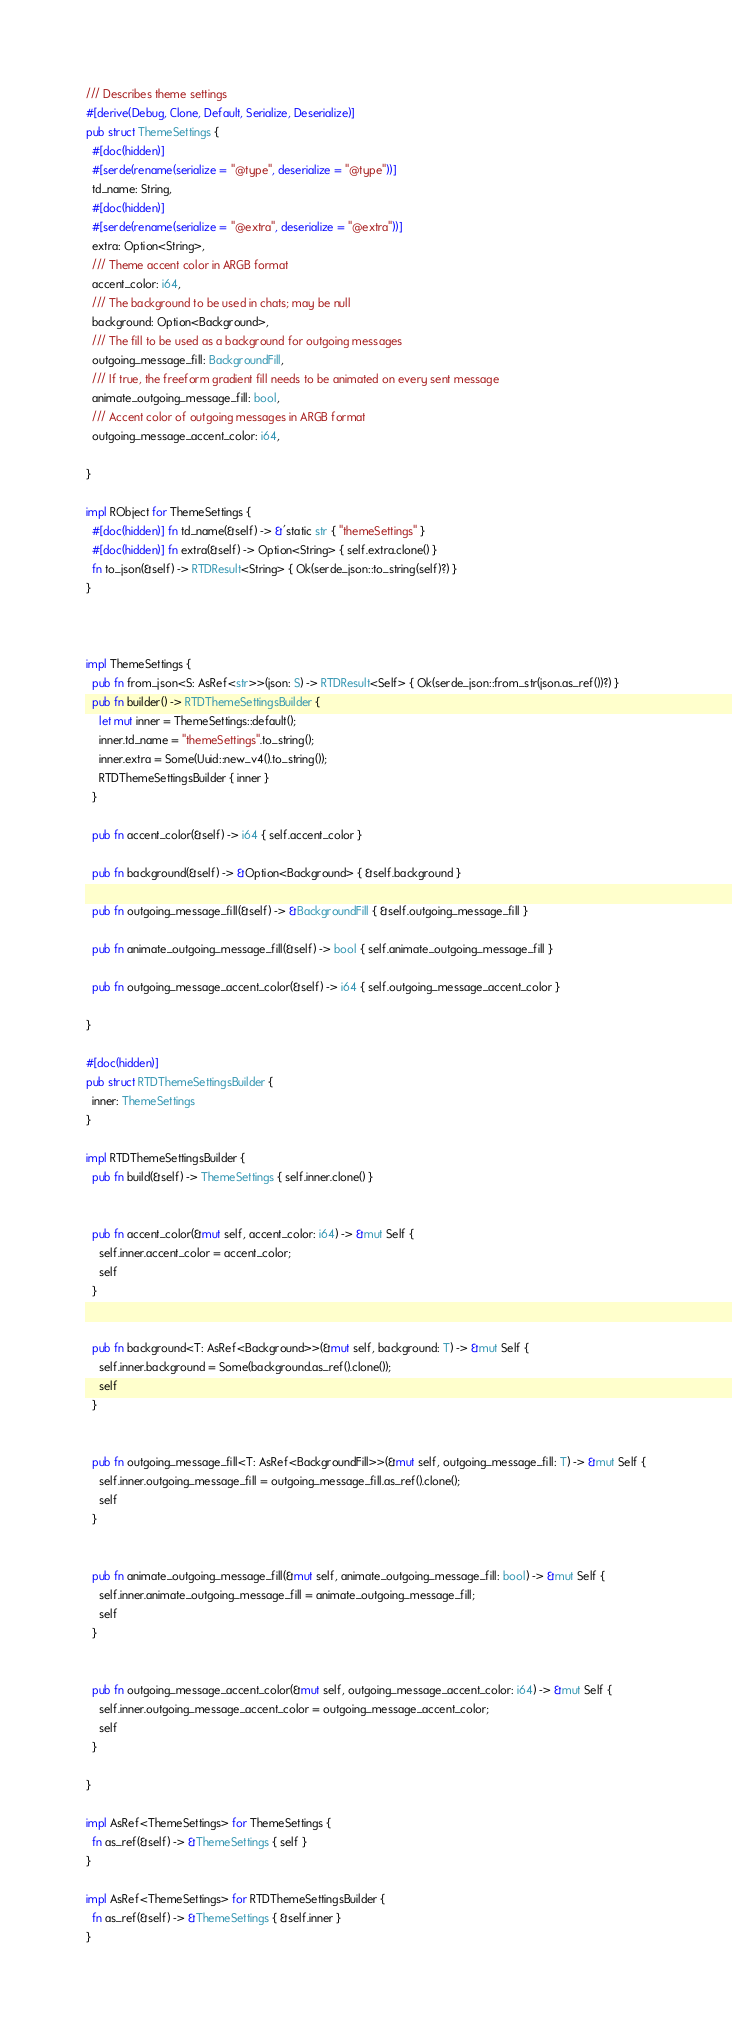Convert code to text. <code><loc_0><loc_0><loc_500><loc_500><_Rust_>


/// Describes theme settings
#[derive(Debug, Clone, Default, Serialize, Deserialize)]
pub struct ThemeSettings {
  #[doc(hidden)]
  #[serde(rename(serialize = "@type", deserialize = "@type"))]
  td_name: String,
  #[doc(hidden)]
  #[serde(rename(serialize = "@extra", deserialize = "@extra"))]
  extra: Option<String>,
  /// Theme accent color in ARGB format
  accent_color: i64,
  /// The background to be used in chats; may be null
  background: Option<Background>,
  /// The fill to be used as a background for outgoing messages
  outgoing_message_fill: BackgroundFill,
  /// If true, the freeform gradient fill needs to be animated on every sent message
  animate_outgoing_message_fill: bool,
  /// Accent color of outgoing messages in ARGB format
  outgoing_message_accent_color: i64,
  
}

impl RObject for ThemeSettings {
  #[doc(hidden)] fn td_name(&self) -> &'static str { "themeSettings" }
  #[doc(hidden)] fn extra(&self) -> Option<String> { self.extra.clone() }
  fn to_json(&self) -> RTDResult<String> { Ok(serde_json::to_string(self)?) }
}



impl ThemeSettings {
  pub fn from_json<S: AsRef<str>>(json: S) -> RTDResult<Self> { Ok(serde_json::from_str(json.as_ref())?) }
  pub fn builder() -> RTDThemeSettingsBuilder {
    let mut inner = ThemeSettings::default();
    inner.td_name = "themeSettings".to_string();
    inner.extra = Some(Uuid::new_v4().to_string());
    RTDThemeSettingsBuilder { inner }
  }

  pub fn accent_color(&self) -> i64 { self.accent_color }

  pub fn background(&self) -> &Option<Background> { &self.background }

  pub fn outgoing_message_fill(&self) -> &BackgroundFill { &self.outgoing_message_fill }

  pub fn animate_outgoing_message_fill(&self) -> bool { self.animate_outgoing_message_fill }

  pub fn outgoing_message_accent_color(&self) -> i64 { self.outgoing_message_accent_color }

}

#[doc(hidden)]
pub struct RTDThemeSettingsBuilder {
  inner: ThemeSettings
}

impl RTDThemeSettingsBuilder {
  pub fn build(&self) -> ThemeSettings { self.inner.clone() }

   
  pub fn accent_color(&mut self, accent_color: i64) -> &mut Self {
    self.inner.accent_color = accent_color;
    self
  }

   
  pub fn background<T: AsRef<Background>>(&mut self, background: T) -> &mut Self {
    self.inner.background = Some(background.as_ref().clone());
    self
  }

   
  pub fn outgoing_message_fill<T: AsRef<BackgroundFill>>(&mut self, outgoing_message_fill: T) -> &mut Self {
    self.inner.outgoing_message_fill = outgoing_message_fill.as_ref().clone();
    self
  }

   
  pub fn animate_outgoing_message_fill(&mut self, animate_outgoing_message_fill: bool) -> &mut Self {
    self.inner.animate_outgoing_message_fill = animate_outgoing_message_fill;
    self
  }

   
  pub fn outgoing_message_accent_color(&mut self, outgoing_message_accent_color: i64) -> &mut Self {
    self.inner.outgoing_message_accent_color = outgoing_message_accent_color;
    self
  }

}

impl AsRef<ThemeSettings> for ThemeSettings {
  fn as_ref(&self) -> &ThemeSettings { self }
}

impl AsRef<ThemeSettings> for RTDThemeSettingsBuilder {
  fn as_ref(&self) -> &ThemeSettings { &self.inner }
}



</code> 